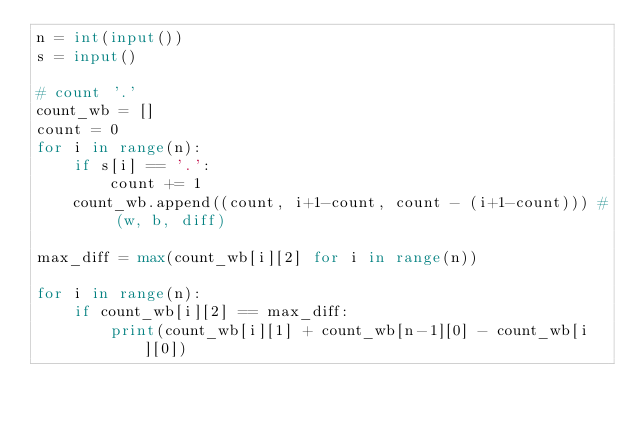<code> <loc_0><loc_0><loc_500><loc_500><_Python_>n = int(input())
s = input()

# count '.'
count_wb = []
count = 0
for i in range(n):
    if s[i] == '.':
        count += 1
    count_wb.append((count, i+1-count, count - (i+1-count))) # (w, b, diff)

max_diff = max(count_wb[i][2] for i in range(n))

for i in range(n):
    if count_wb[i][2] == max_diff:
        print(count_wb[i][1] + count_wb[n-1][0] - count_wb[i][0])
</code> 